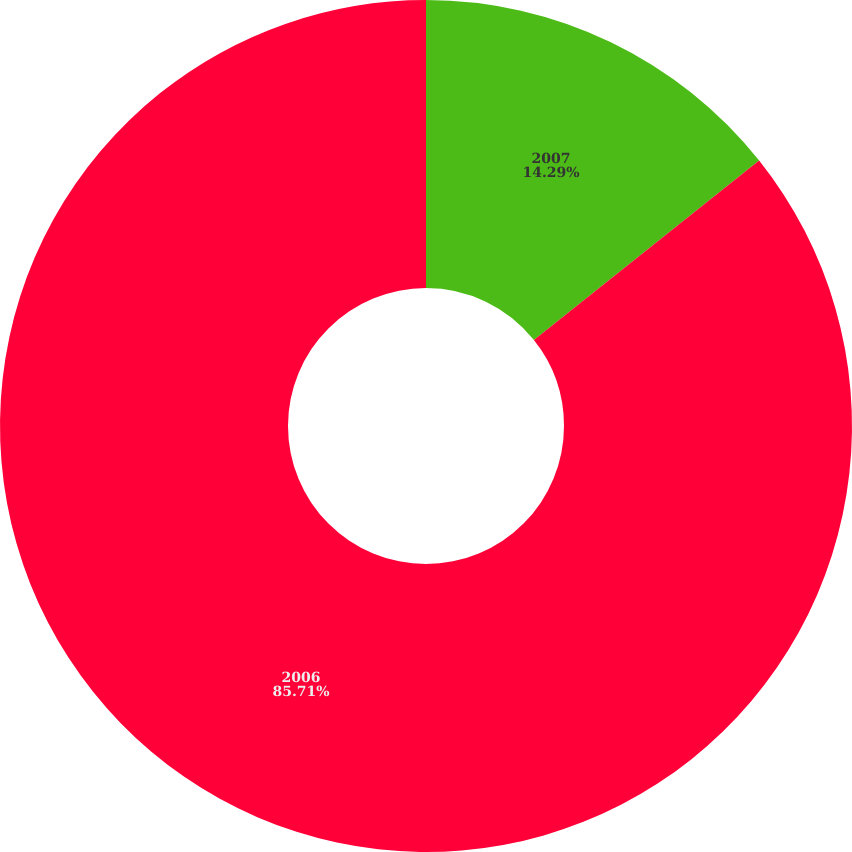Convert chart. <chart><loc_0><loc_0><loc_500><loc_500><pie_chart><fcel>2007<fcel>2006<nl><fcel>14.29%<fcel>85.71%<nl></chart> 